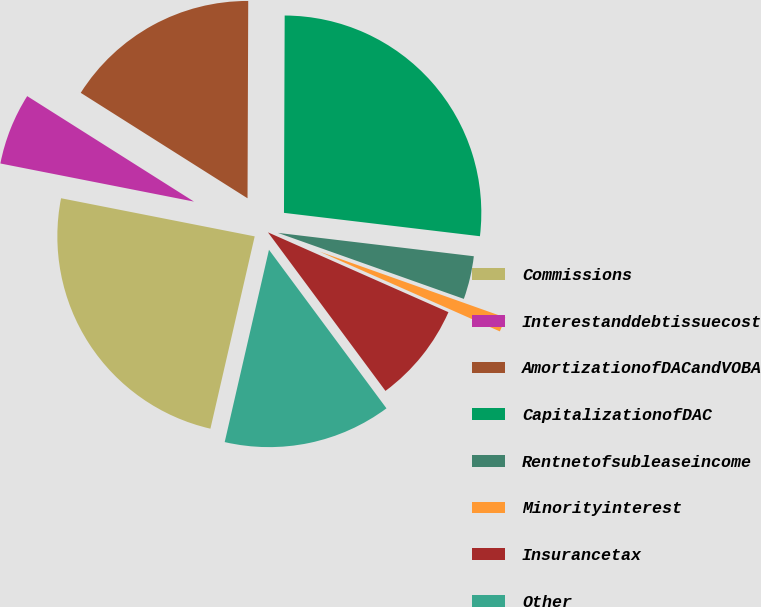Convert chart. <chart><loc_0><loc_0><loc_500><loc_500><pie_chart><fcel>Commissions<fcel>Interestanddebtissuecost<fcel>AmortizationofDACandVOBA<fcel>CapitalizationofDAC<fcel>Rentnetofsubleaseincome<fcel>Minorityinterest<fcel>Insurancetax<fcel>Other<nl><fcel>24.49%<fcel>5.88%<fcel>16.08%<fcel>26.83%<fcel>3.54%<fcel>1.2%<fcel>8.22%<fcel>13.75%<nl></chart> 